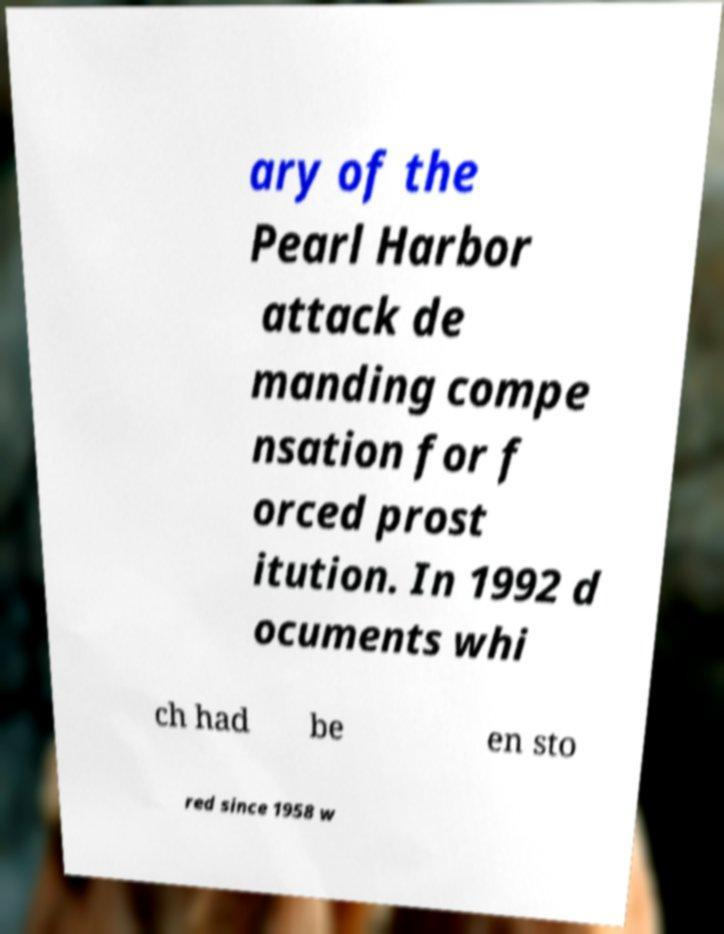I need the written content from this picture converted into text. Can you do that? ary of the Pearl Harbor attack de manding compe nsation for f orced prost itution. In 1992 d ocuments whi ch had be en sto red since 1958 w 